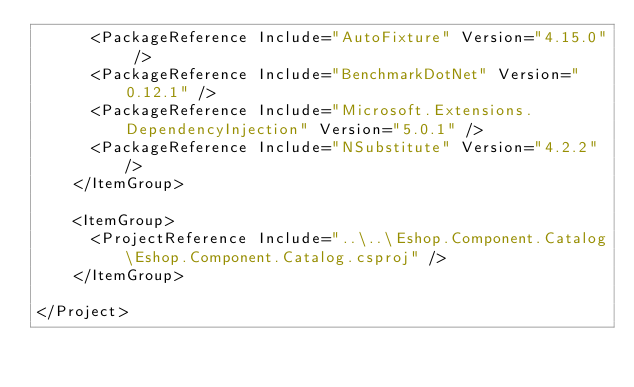Convert code to text. <code><loc_0><loc_0><loc_500><loc_500><_XML_>      <PackageReference Include="AutoFixture" Version="4.15.0" />
      <PackageReference Include="BenchmarkDotNet" Version="0.12.1" />
      <PackageReference Include="Microsoft.Extensions.DependencyInjection" Version="5.0.1" />
      <PackageReference Include="NSubstitute" Version="4.2.2" />
    </ItemGroup>

    <ItemGroup>
      <ProjectReference Include="..\..\Eshop.Component.Catalog\Eshop.Component.Catalog.csproj" />
    </ItemGroup>

</Project>
</code> 